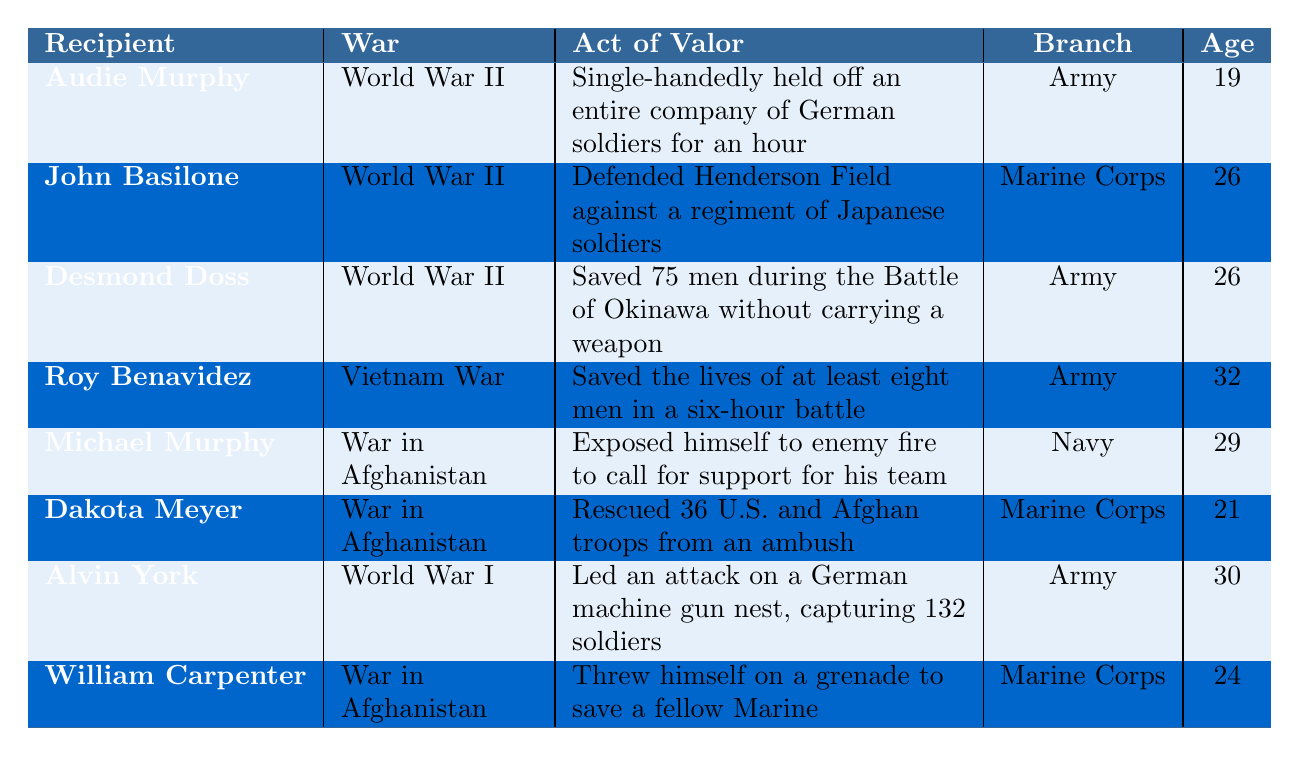What is the age of Audie Murphy when he was awarded the Medal of Honor? The table lists the age at which Audie Murphy received the Medal of Honor, which is recorded as 19.
Answer: 19 In which war did Roy Benavidez perform his act of valor? The table indicates that Roy Benavidez's act of valor occurred during the Vietnam War.
Answer: Vietnam War How many soldiers did Desmond Doss save during the Battle of Okinawa? The table specifies that Desmond Doss saved 75 men during the Battle of Okinawa.
Answer: 75 Which branch of the military recognized Michael Murphy for his valor? According to the table, Michael Murphy was recognized by the Navy for his valor.
Answer: Navy Who was the youngest Medal of Honor recipient in this table? By comparing the ages at the time of awarding, Dakota Meyer at age 21 is the youngest recipient noted.
Answer: Dakota Meyer How many Medal of Honor recipients are from World War II? The table shows three recipients (Audie Murphy, John Basilone, and Desmond Doss) who received the Medal of Honor for actions in World War II.
Answer: 3 Is it true that William Carpenter received the Medal of Honor for his actions in the War in Afghanistan? The table confirms that William Carpenter's act of valor took place during the War in Afghanistan, making this statement true.
Answer: Yes What was the average age of recipients when they received the Medal of Honor? To find the average, add the ages (19 + 26 + 26 + 32 + 29 + 21 + 30 + 24 =  207) and divide by the number of recipients (8), giving an average age of 25.875.
Answer: 25.875 Which recipient was involved in saving the lives of the greatest number of individuals? Desmond Doss saved 75 men, which is the highest number mentioned among the recipients in the table.
Answer: Desmond Doss How many recipients were awarded the Medal of Honor after the year 2000? From the table, there are three recipients (Michael Murphy, Dakota Meyer, and William Carpenter) who were awarded the Medal of Honor after the year 2000.
Answer: 3 